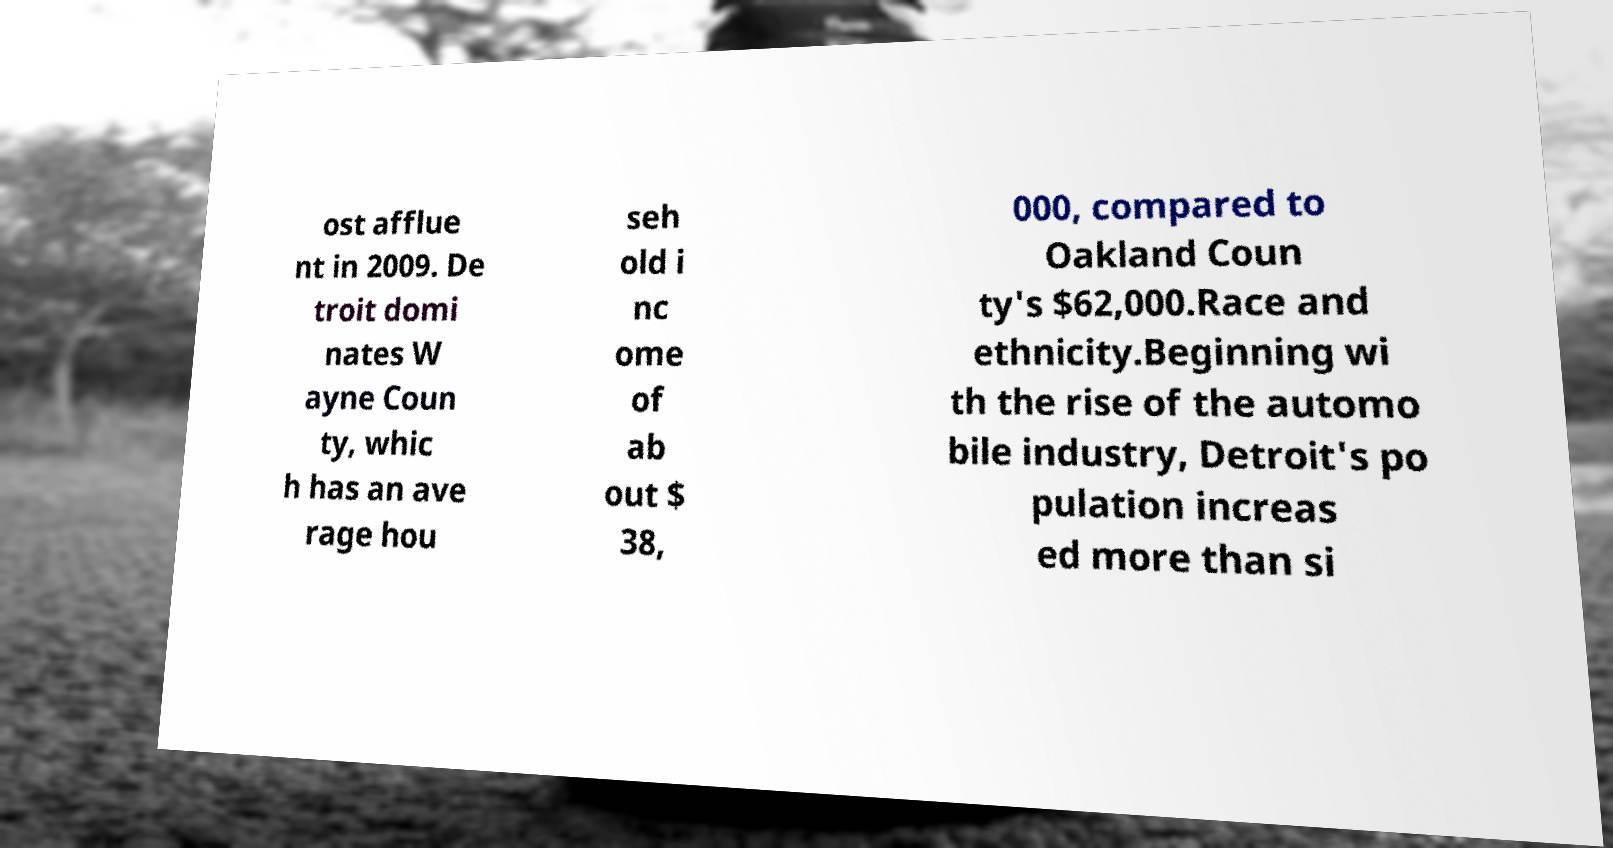Could you assist in decoding the text presented in this image and type it out clearly? ost afflue nt in 2009. De troit domi nates W ayne Coun ty, whic h has an ave rage hou seh old i nc ome of ab out $ 38, 000, compared to Oakland Coun ty's $62,000.Race and ethnicity.Beginning wi th the rise of the automo bile industry, Detroit's po pulation increas ed more than si 